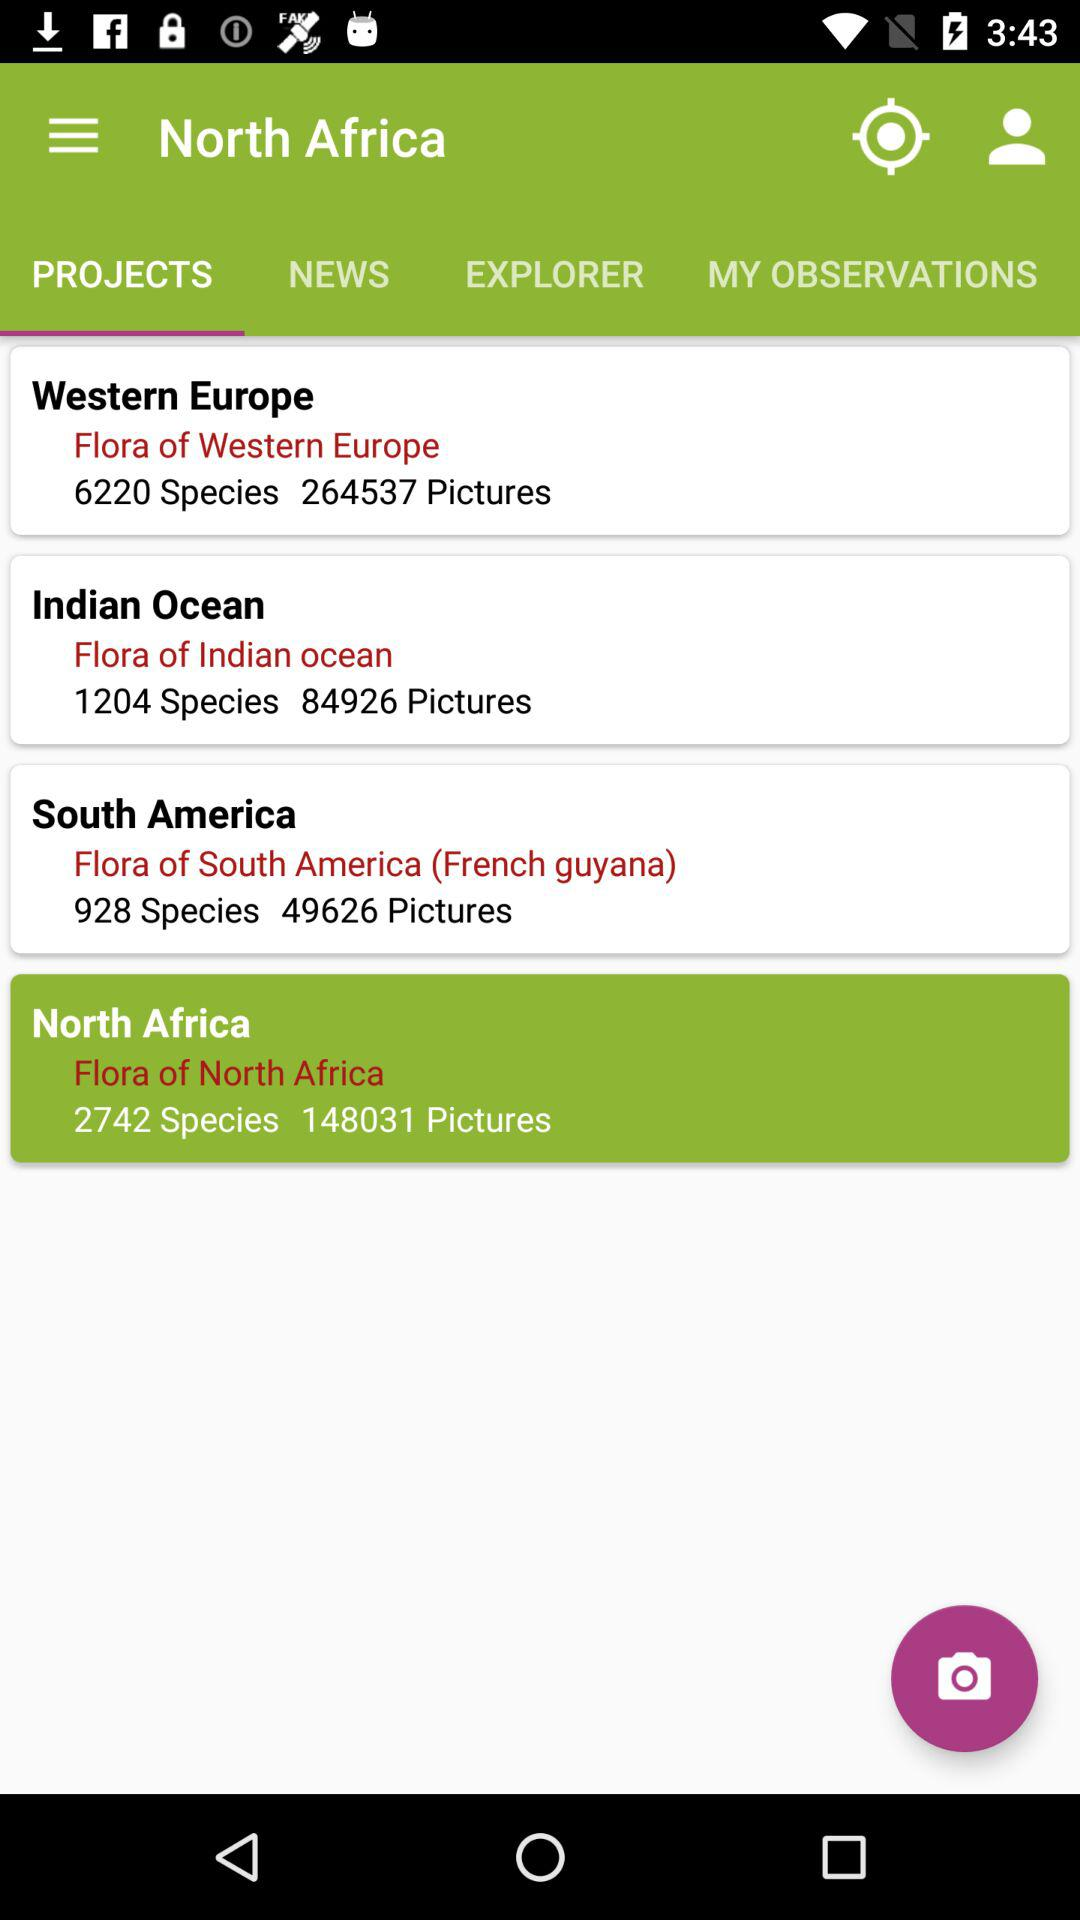What's the selected tab? The selected tab is "PROJECTS". 